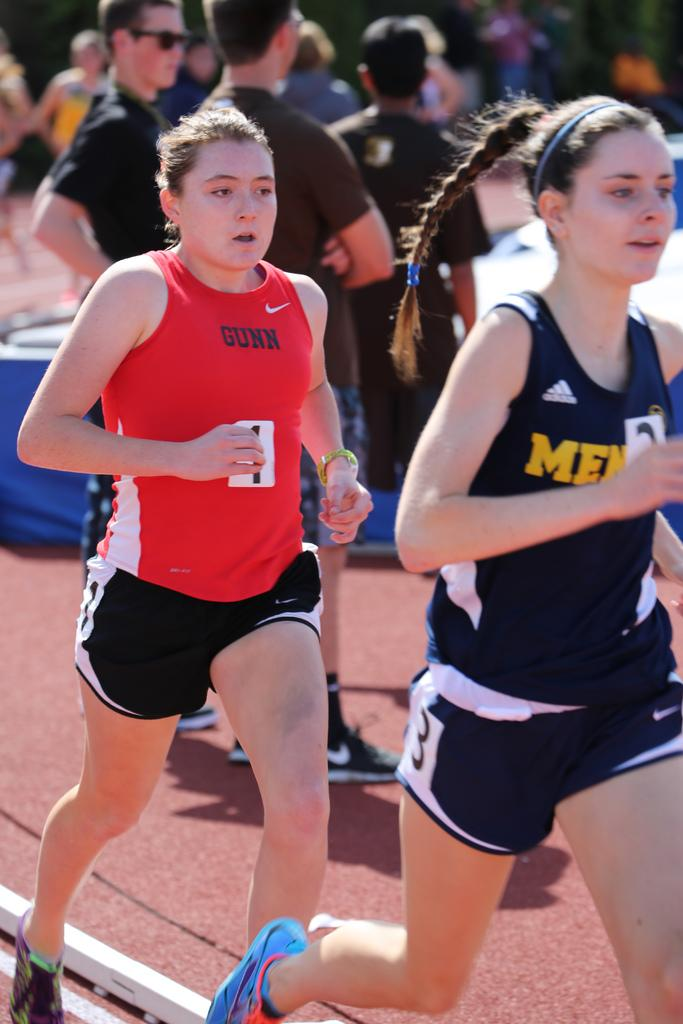Provide a one-sentence caption for the provided image. a girl running with the word Gunn on her shirt. 